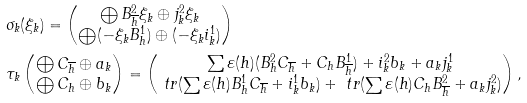<formula> <loc_0><loc_0><loc_500><loc_500>& \sigma _ { k } ( \xi _ { k } ) = \begin{pmatrix} \bigoplus B ^ { 2 } _ { \overline { h } } \xi _ { k } \oplus j ^ { 2 } _ { k } \xi _ { k } \\ \bigoplus ( - \xi _ { k } B ^ { 1 } _ { h } ) \oplus ( - \xi _ { k } i ^ { 1 } _ { k } ) \end{pmatrix} \\ & \tau _ { k } \begin{pmatrix} \bigoplus C _ { \overline { h } } \oplus a _ { k } \\ \bigoplus C _ { h } \oplus b _ { k } \end{pmatrix} = \begin{pmatrix} \sum \varepsilon ( h ) ( B ^ { 2 } _ { h } C _ { \overline { h } } + C _ { h } B ^ { 1 } _ { \overline { h } } ) + i ^ { 2 } _ { k } b _ { k } + a _ { k } j ^ { 1 } _ { k } \\ \ t r ( \sum \varepsilon ( h ) B ^ { 1 } _ { h } C _ { \overline { h } } + i ^ { 1 } _ { k } b _ { k } ) + \ t r ( \sum \varepsilon ( h ) C _ { h } B ^ { 2 } _ { \overline { h } } + a _ { k } j ^ { 2 } _ { k } ) \end{pmatrix} ,</formula> 